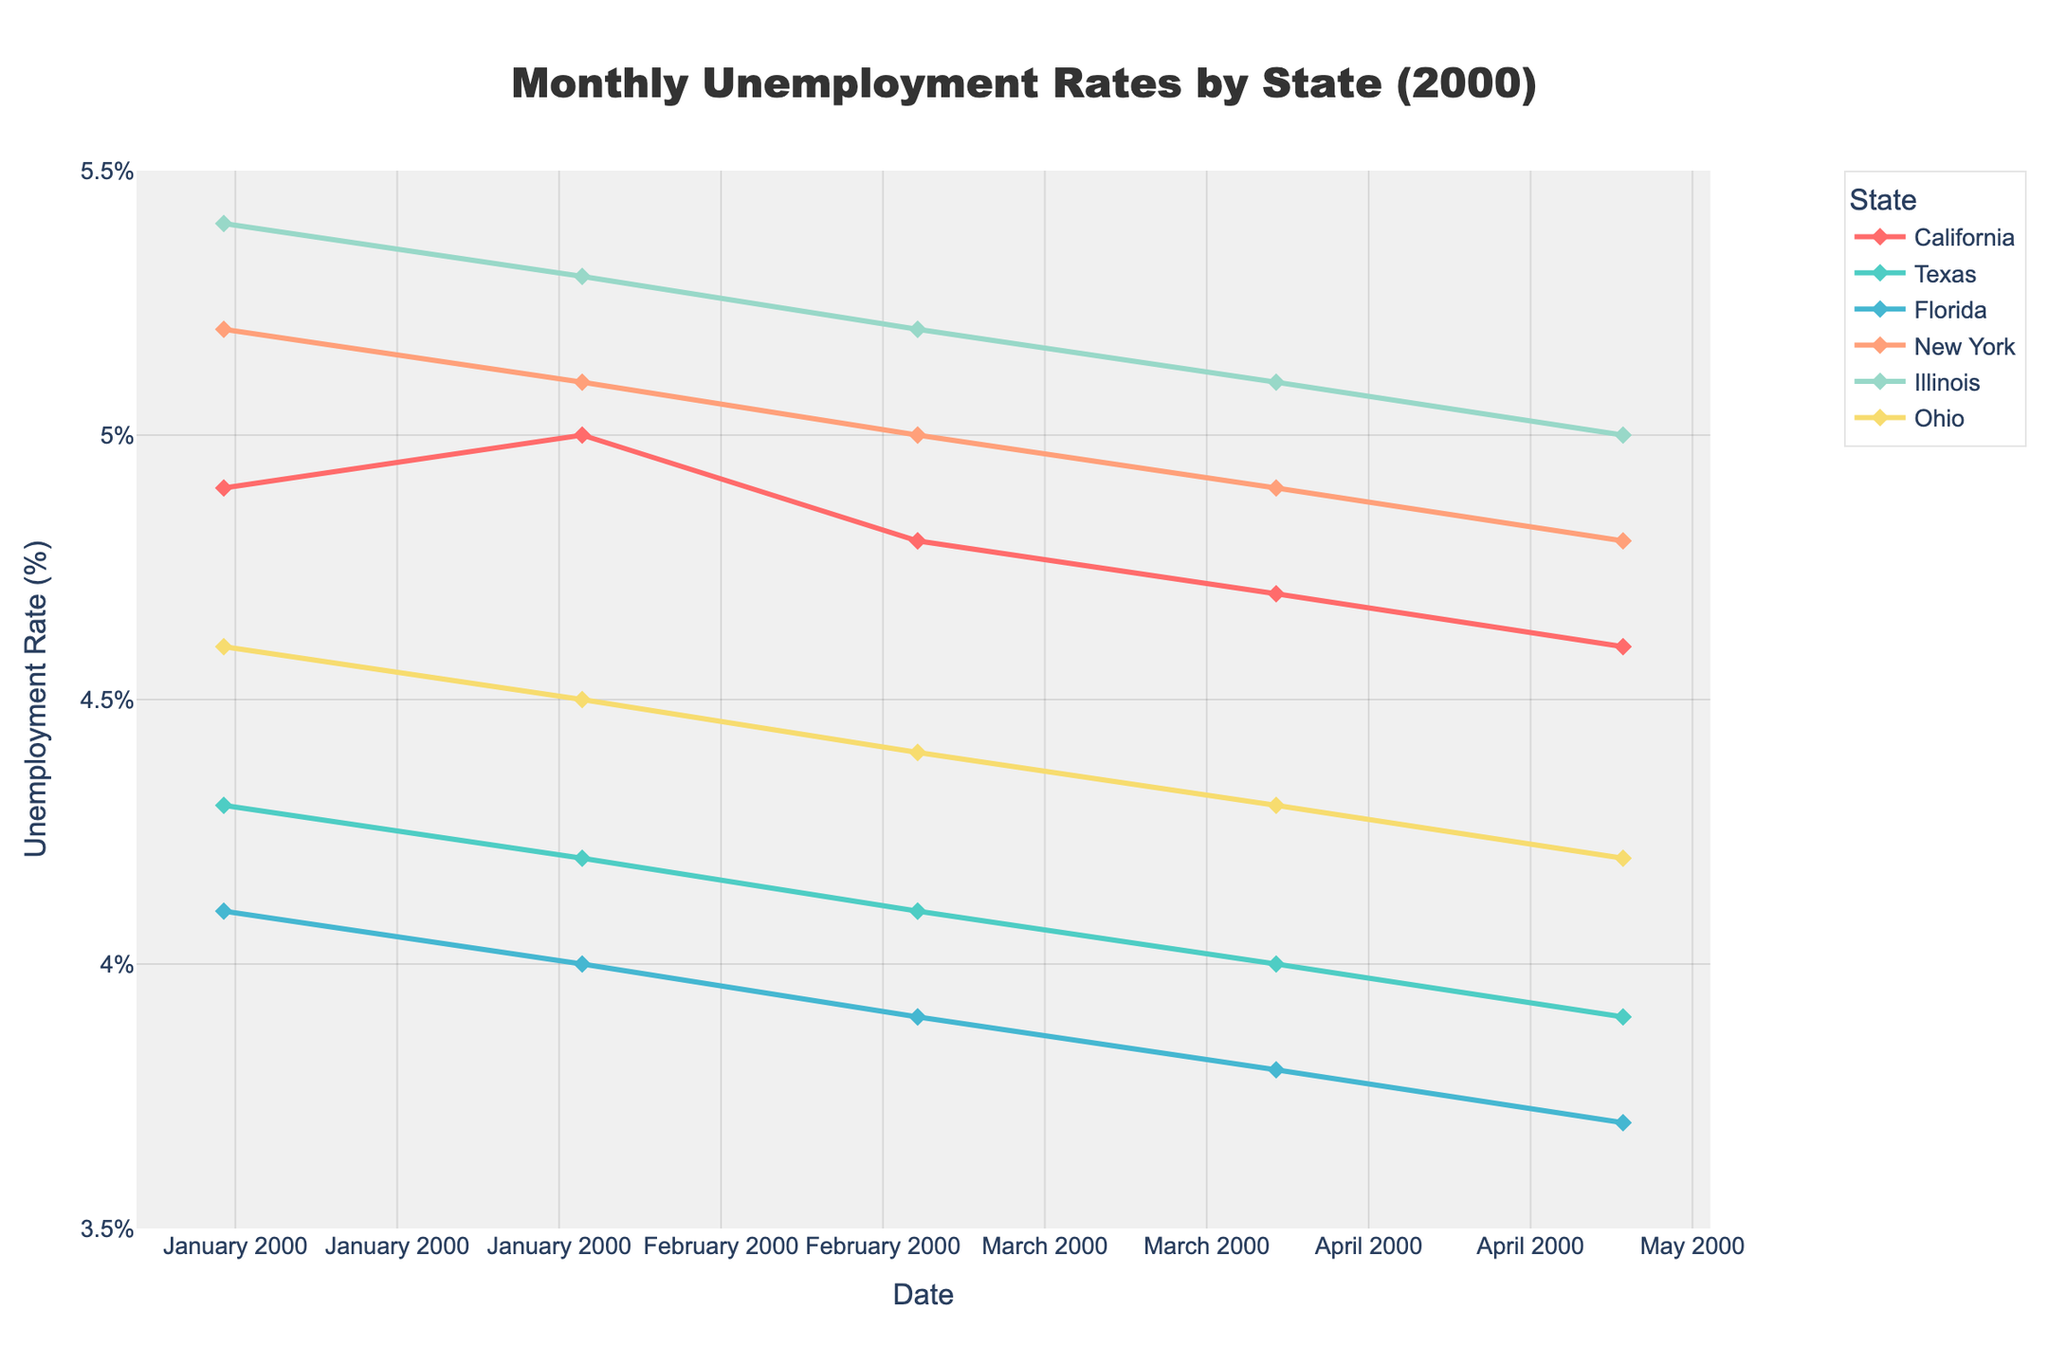What is the title of the figure? The title is displayed prominently at the top center of the plot, providing a clear summary of the data portrayed in the figure.
Answer: Monthly Unemployment Rates by State (2000) What are the units of the y-axis? The y-axis title states the units, indicating what measurement is being displayed.
Answer: Unemployment Rate (%) How many states are represented in the figure? By counting the distinct lines in the legend, we can determine the number of different states shown in the figure.
Answer: 6 Which state had the highest unemployment rate in January 2000? By observing the data points for January 2000, we identify which state’s line reaches the highest value on the y-axis.
Answer: Illinois Which state shows the most consistent decline in unemployment rate from January to May 2000? By analyzing the slopes of the lines from January to May 2000, the state with the steepest constant decline can be identified.
Answer: Florida What is the range of unemployment rates observed in the figure? The minimum and maximum values on the y-axis provide the range of observed unemployment rates in the figure.
Answer: 3.7% to 5.4% Which state had the lowest unemployment rate in May 2000? Comparing the data points for May 2000, we identify the state whose line reaches the lowest value on the y-axis.
Answer: Florida Which states had an unemployment rate of 4.8% at any time in 2000? By examining y-axis data points and corresponding state lines, we can identify states hitting 4.8% at least once.
Answer: California, New York By how much did the unemployment rate change for Texas from January 2000 to May 2000? Subtract the unemployment rate in May from the rate in January for Texas to find the difference.
Answer: 4.3% - 3.9% = 0.4% Which state had the greatest fluctuation in unemployment rate from January to May 2000? Identify the state with the largest difference between its highest and lowest unemployment rate within this period.
Answer: Illinois 